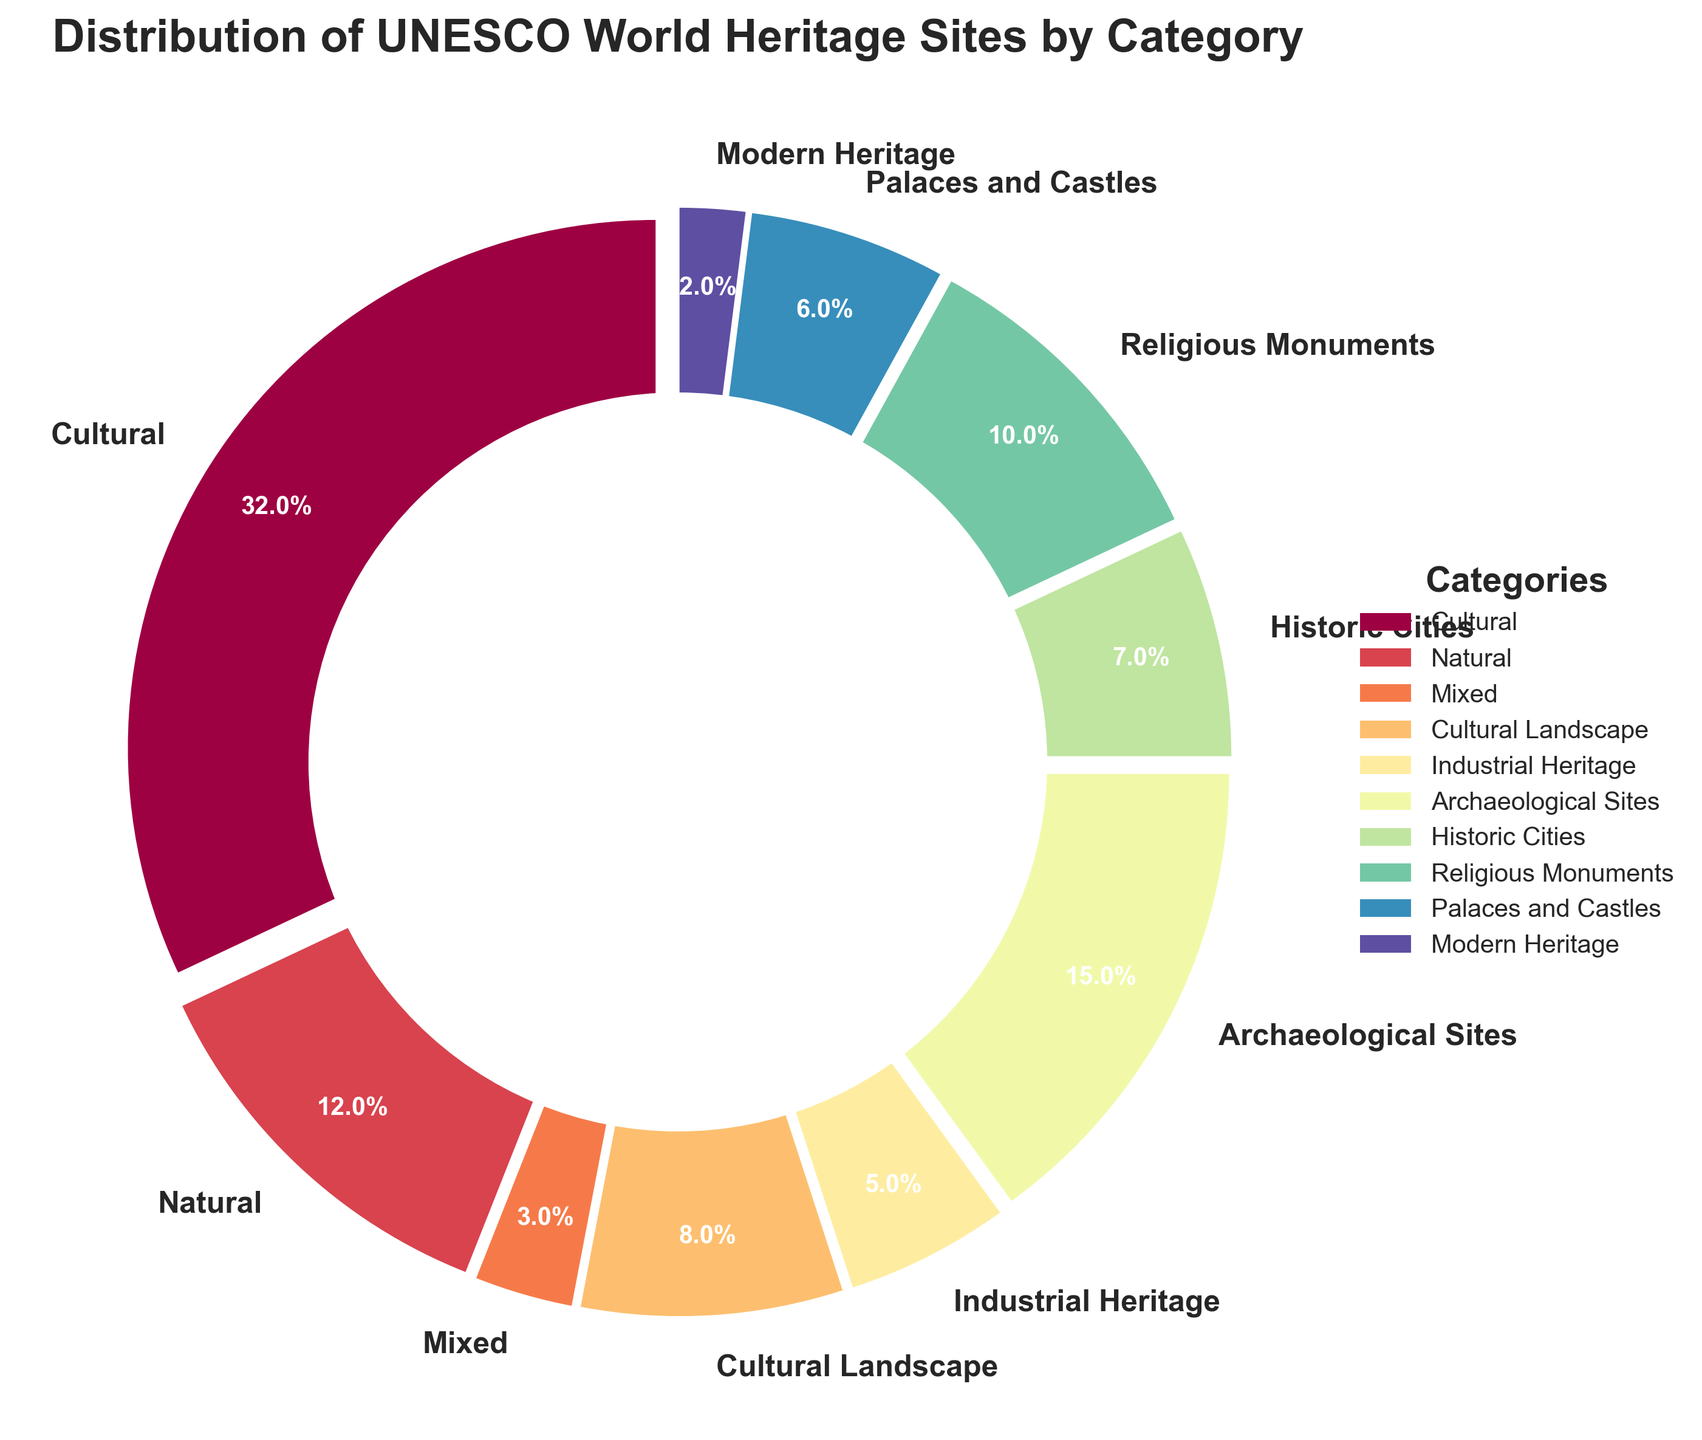Which category has the highest number of UNESCO World Heritage sites? To find the category with the highest number of sites, look for the category with the largest slice in the pie chart. The largest slice is labeled "Cultural" with 32 sites.
Answer: Cultural Which categories have fewer than 5 UNESCO World Heritage sites? Identify the slices in the pie chart with numbers less than 5. "Mixed" with 3 sites and "Modern Heritage" with 2 sites are the categories with fewer than 5 sites.
Answer: Mixed, Modern Heritage What is the combined percentage of Cultural Sites and Archaeological Sites? Find the percentages for "Cultural" (32 sites) and "Archaeological Sites" (15 sites), then add these percentages. Cultural Sites have approximately 42.1% and Archaeological Sites have about 19.7%. Adding these gives us approximately 61.8%.
Answer: 61.8% How does the number of Natural sites compare to Religious Monuments? Compare the number of sites for the categories "Natural" (12 sites) and "Religious Monuments" (10 sites). Natural sites are more numerous by 2.
Answer: Natural sites have 2 more What is the difference in the number of sites between Cultural and Modern Heritage categories? Calculate the difference in numbers between "Cultural" (32 sites) and "Modern Heritage" (2 sites). The difference is 32 - 2 = 30.
Answer: 30 Which slice has a green color and what does it represent? Examine the slices of the pie chart and identify the one with a greenish hue. Then, read the label attached to this slice. In many color palettes used in plotting, the green slice often represents "Natural" sites.
Answer: Natural What proportion of the total sites are Industrial Heritage sites? Look for the "Industrial Heritage" slice and read its percentage from the pie chart. Industrial Heritage has 5 sites. To confirm, calculate (5/100) * 100% ≈ 6.6%.
Answer: 6.6% Which category has the second-largest number of sites? Identify the slice with the second largest size next to "Cultural". The second largest slice is "Archaeological Sites" with 15 sites.
Answer: Archaeological Sites Is the number of Historic Cities sites greater than that for Palaces and Castles? Compare the numbers of "Historic Cities" (7 sites) and "Palaces and Castles" (6 sites). Historic Cities have 1 more site.
Answer: Yes What is the total number of sites for Historic Cities and Cultural Landscape categories combined? Add the number of sites in "Historic Cities" (7 sites) and "Cultural Landscape" (8 sites). The total is 7 + 8 = 15.
Answer: 15 